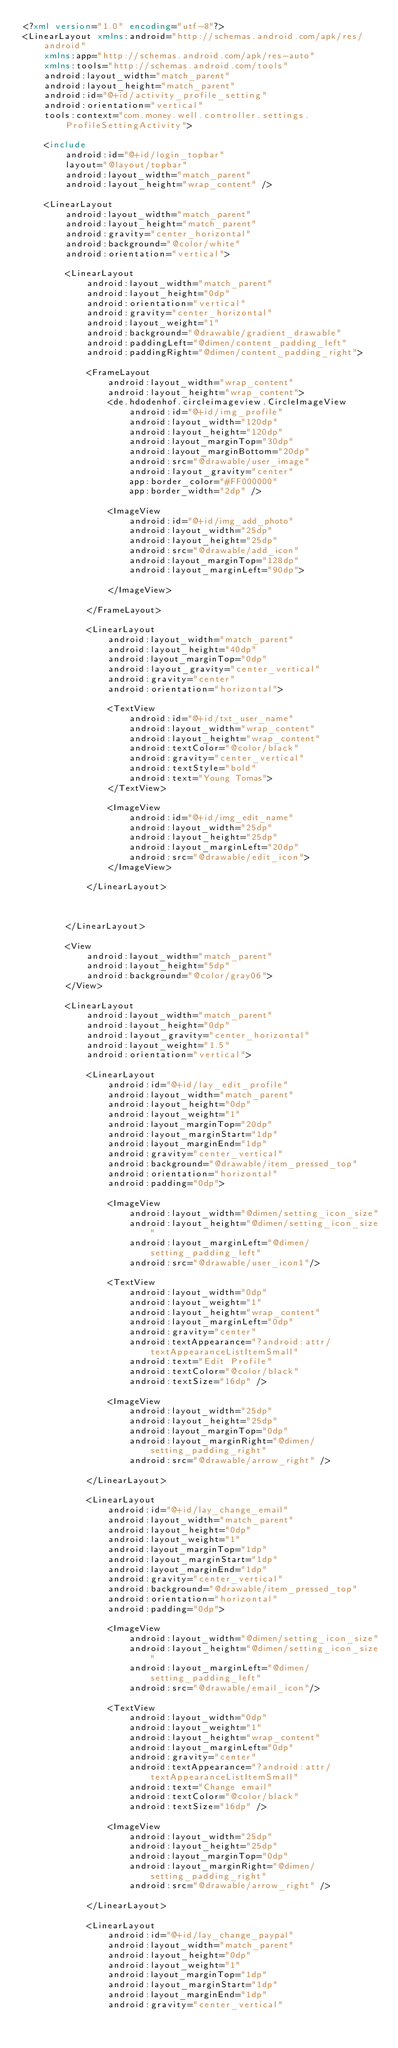Convert code to text. <code><loc_0><loc_0><loc_500><loc_500><_XML_><?xml version="1.0" encoding="utf-8"?>
<LinearLayout xmlns:android="http://schemas.android.com/apk/res/android"
    xmlns:app="http://schemas.android.com/apk/res-auto"
    xmlns:tools="http://schemas.android.com/tools"
    android:layout_width="match_parent"
    android:layout_height="match_parent"
    android:id="@+id/activity_profile_setting"
    android:orientation="vertical"
    tools:context="com.money.well.controller.settings.ProfileSettingActivity">

    <include
        android:id="@+id/login_topbar"
        layout="@layout/topbar"
        android:layout_width="match_parent"
        android:layout_height="wrap_content" />

    <LinearLayout
        android:layout_width="match_parent"
        android:layout_height="match_parent"
        android:gravity="center_horizontal"
        android:background="@color/white"
        android:orientation="vertical">

        <LinearLayout
            android:layout_width="match_parent"
            android:layout_height="0dp"
            android:orientation="vertical"
            android:gravity="center_horizontal"
            android:layout_weight="1"
            android:background="@drawable/gradient_drawable"
            android:paddingLeft="@dimen/content_padding_left"
            android:paddingRight="@dimen/content_padding_right">

            <FrameLayout
                android:layout_width="wrap_content"
                android:layout_height="wrap_content">
                <de.hdodenhof.circleimageview.CircleImageView
                    android:id="@+id/img_profile"
                    android:layout_width="120dp"
                    android:layout_height="120dp"
                    android:layout_marginTop="30dp"
                    android:layout_marginBottom="20dp"
                    android:src="@drawable/user_image"
                    android:layout_gravity="center"
                    app:border_color="#FF000000"
                    app:border_width="2dp" />

                <ImageView
                    android:id="@+id/img_add_photo"
                    android:layout_width="25dp"
                    android:layout_height="25dp"
                    android:src="@drawable/add_icon"
                    android:layout_marginTop="128dp"
                    android:layout_marginLeft="90dp">

                </ImageView>

            </FrameLayout>

            <LinearLayout
                android:layout_width="match_parent"
                android:layout_height="40dp"
                android:layout_marginTop="0dp"
                android:layout_gravity="center_vertical"
                android:gravity="center"
                android:orientation="horizontal">

                <TextView
                    android:id="@+id/txt_user_name"
                    android:layout_width="wrap_content"
                    android:layout_height="wrap_content"
                    android:textColor="@color/black"
                    android:gravity="center_vertical"
                    android:textStyle="bold"
                    android:text="Young Tomas">
                </TextView>

                <ImageView
                    android:id="@+id/img_edit_name"
                    android:layout_width="25dp"
                    android:layout_height="25dp"
                    android:layout_marginLeft="20dp"
                    android:src="@drawable/edit_icon">
                </ImageView>

            </LinearLayout>



        </LinearLayout>

        <View
            android:layout_width="match_parent"
            android:layout_height="5dp"
            android:background="@color/gray06">
        </View>

        <LinearLayout
            android:layout_width="match_parent"
            android:layout_height="0dp"
            android:layout_gravity="center_horizontal"
            android:layout_weight="1.5"
            android:orientation="vertical">

            <LinearLayout
                android:id="@+id/lay_edit_profile"
                android:layout_width="match_parent"
                android:layout_height="0dp"
                android:layout_weight="1"
                android:layout_marginTop="20dp"
                android:layout_marginStart="1dp"
                android:layout_marginEnd="1dp"
                android:gravity="center_vertical"
                android:background="@drawable/item_pressed_top"
                android:orientation="horizontal"
                android:padding="0dp">

                <ImageView
                    android:layout_width="@dimen/setting_icon_size"
                    android:layout_height="@dimen/setting_icon_size"
                    android:layout_marginLeft="@dimen/setting_padding_left"
                    android:src="@drawable/user_icon1"/>

                <TextView
                    android:layout_width="0dp"
                    android:layout_weight="1"
                    android:layout_height="wrap_content"
                    android:layout_marginLeft="0dp"
                    android:gravity="center"
                    android:textAppearance="?android:attr/textAppearanceListItemSmall"
                    android:text="Edit Profile"
                    android:textColor="@color/black"
                    android:textSize="16dp" />

                <ImageView
                    android:layout_width="25dp"
                    android:layout_height="25dp"
                    android:layout_marginTop="0dp"
                    android:layout_marginRight="@dimen/setting_padding_right"
                    android:src="@drawable/arrow_right" />

            </LinearLayout>

            <LinearLayout
                android:id="@+id/lay_change_email"
                android:layout_width="match_parent"
                android:layout_height="0dp"
                android:layout_weight="1"
                android:layout_marginTop="1dp"
                android:layout_marginStart="1dp"
                android:layout_marginEnd="1dp"
                android:gravity="center_vertical"
                android:background="@drawable/item_pressed_top"
                android:orientation="horizontal"
                android:padding="0dp">

                <ImageView
                    android:layout_width="@dimen/setting_icon_size"
                    android:layout_height="@dimen/setting_icon_size"
                    android:layout_marginLeft="@dimen/setting_padding_left"
                    android:src="@drawable/email_icon"/>

                <TextView
                    android:layout_width="0dp"
                    android:layout_weight="1"
                    android:layout_height="wrap_content"
                    android:layout_marginLeft="0dp"
                    android:gravity="center"
                    android:textAppearance="?android:attr/textAppearanceListItemSmall"
                    android:text="Change email"
                    android:textColor="@color/black"
                    android:textSize="16dp" />

                <ImageView
                    android:layout_width="25dp"
                    android:layout_height="25dp"
                    android:layout_marginTop="0dp"
                    android:layout_marginRight="@dimen/setting_padding_right"
                    android:src="@drawable/arrow_right" />

            </LinearLayout>

            <LinearLayout
                android:id="@+id/lay_change_paypal"
                android:layout_width="match_parent"
                android:layout_height="0dp"
                android:layout_weight="1"
                android:layout_marginTop="1dp"
                android:layout_marginStart="1dp"
                android:layout_marginEnd="1dp"
                android:gravity="center_vertical"</code> 